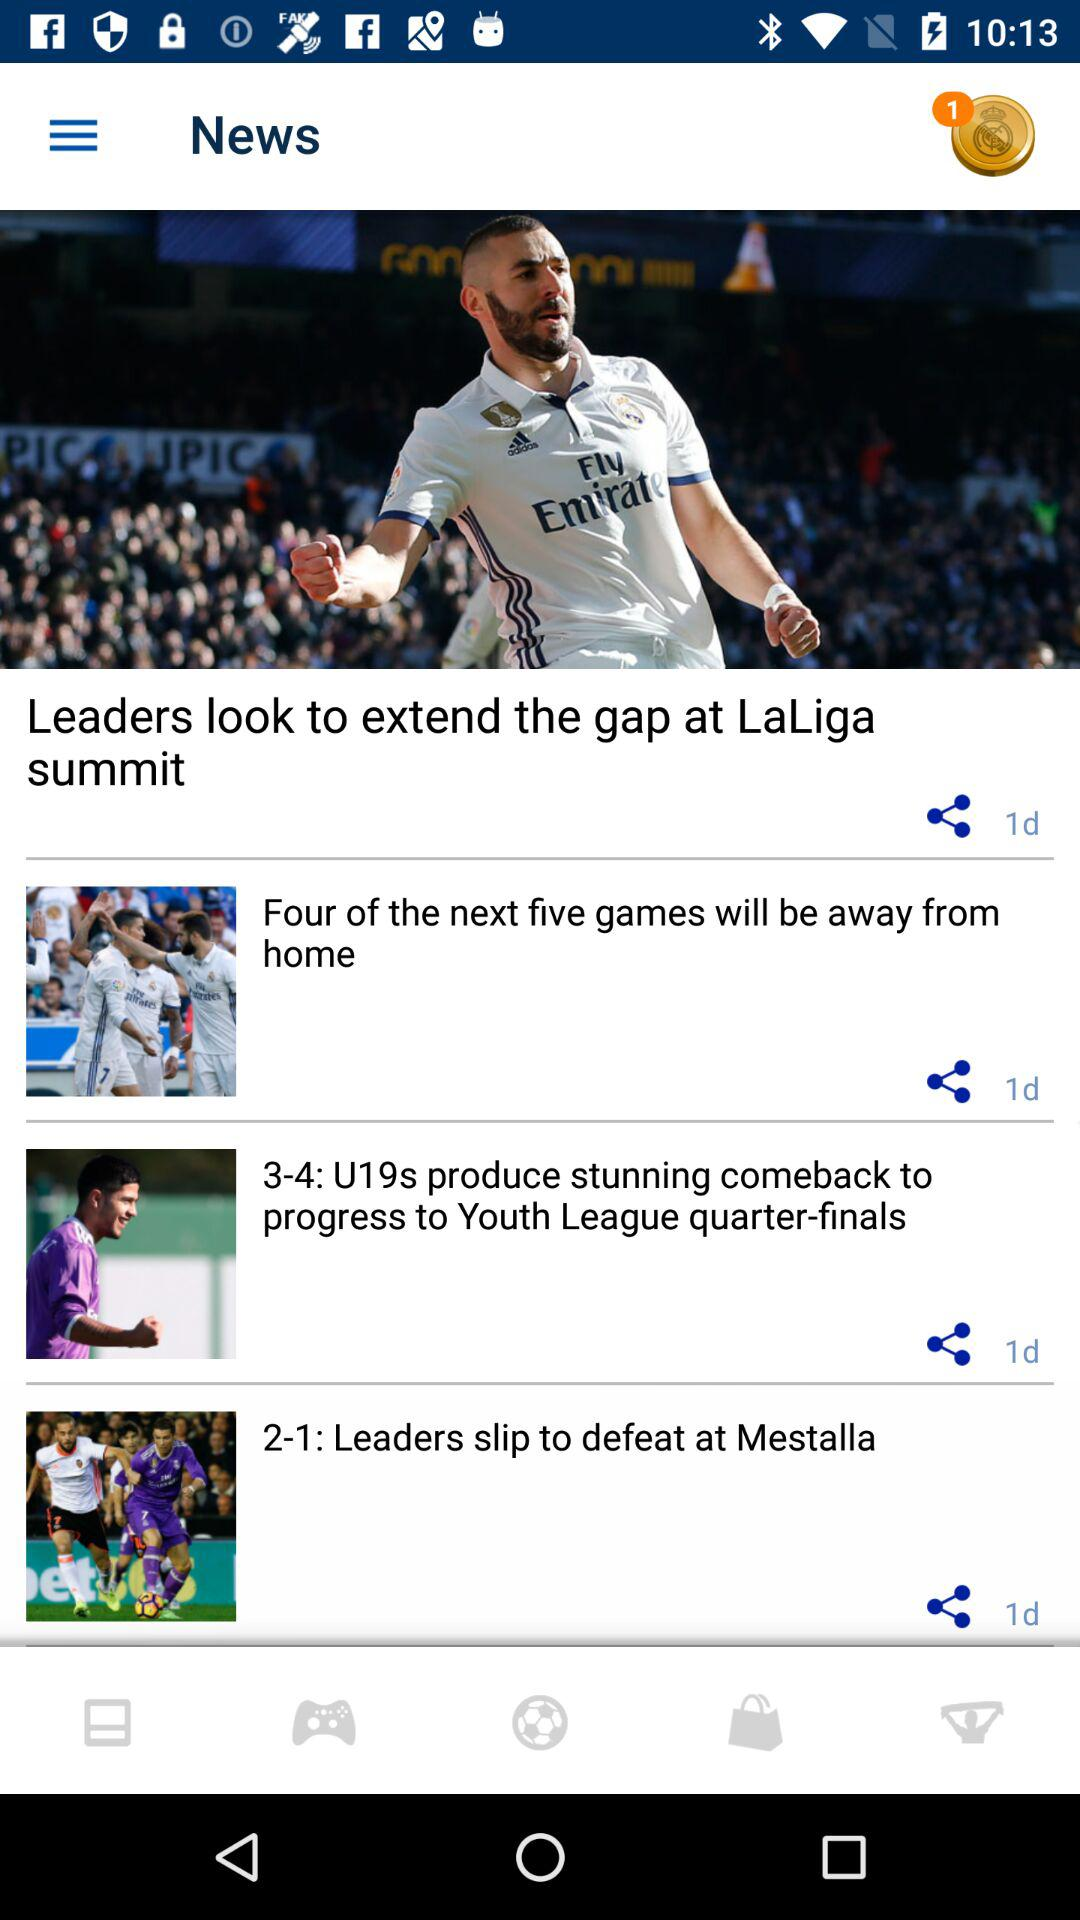Is there an unread notification? There is 1 unread notification. 